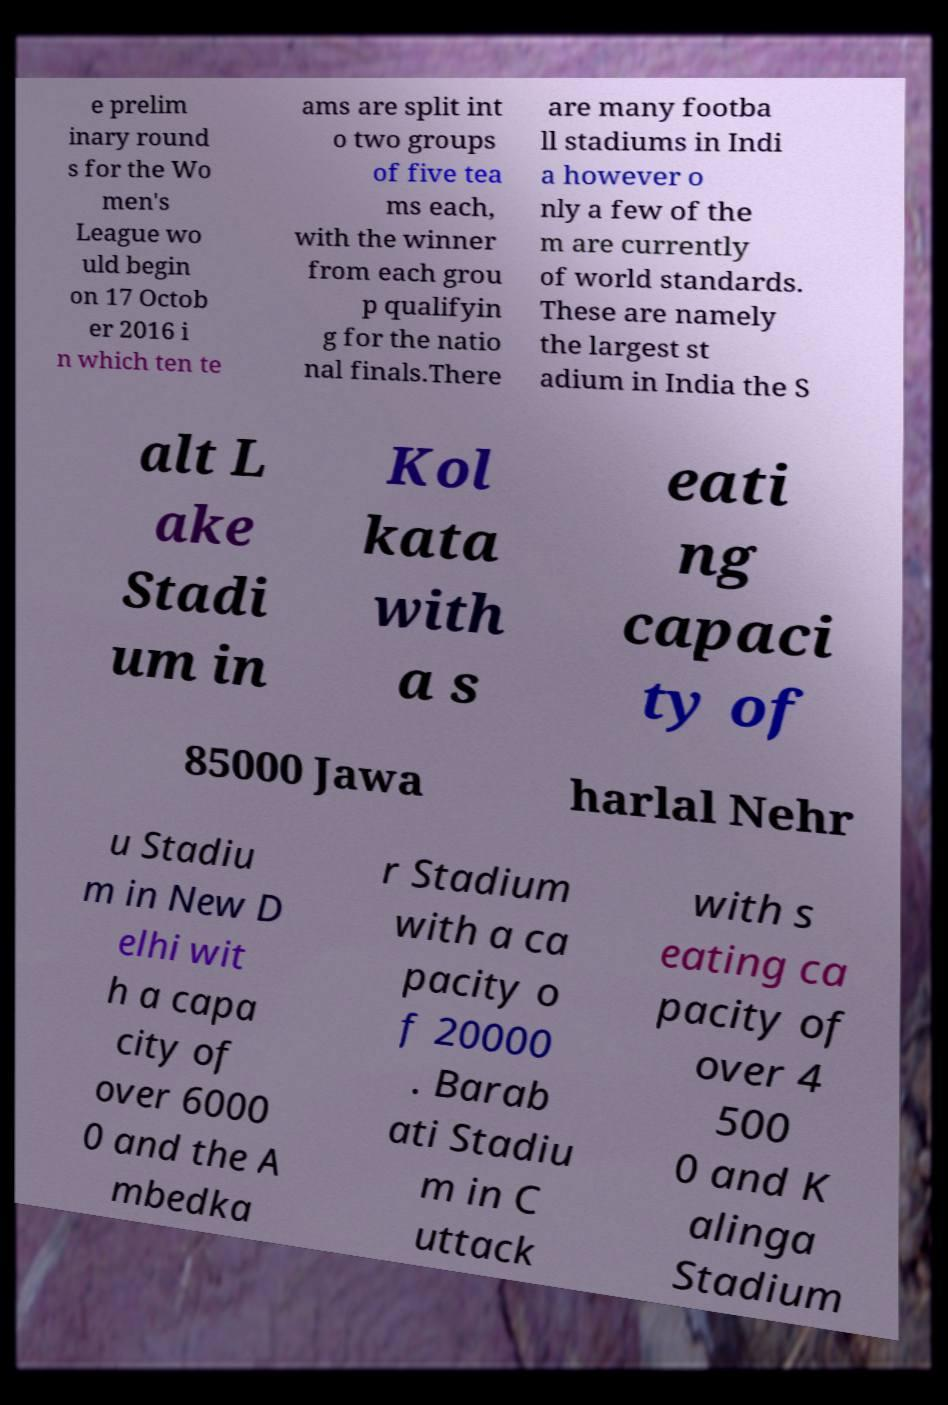Could you assist in decoding the text presented in this image and type it out clearly? e prelim inary round s for the Wo men's League wo uld begin on 17 Octob er 2016 i n which ten te ams are split int o two groups of five tea ms each, with the winner from each grou p qualifyin g for the natio nal finals.There are many footba ll stadiums in Indi a however o nly a few of the m are currently of world standards. These are namely the largest st adium in India the S alt L ake Stadi um in Kol kata with a s eati ng capaci ty of 85000 Jawa harlal Nehr u Stadiu m in New D elhi wit h a capa city of over 6000 0 and the A mbedka r Stadium with a ca pacity o f 20000 . Barab ati Stadiu m in C uttack with s eating ca pacity of over 4 500 0 and K alinga Stadium 